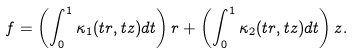<formula> <loc_0><loc_0><loc_500><loc_500>f = \left ( \int _ { 0 } ^ { 1 } \kappa _ { 1 } ( t r , t z ) d t \right ) r + \left ( \int _ { 0 } ^ { 1 } \kappa _ { 2 } ( t r , t z ) d t \right ) z .</formula> 